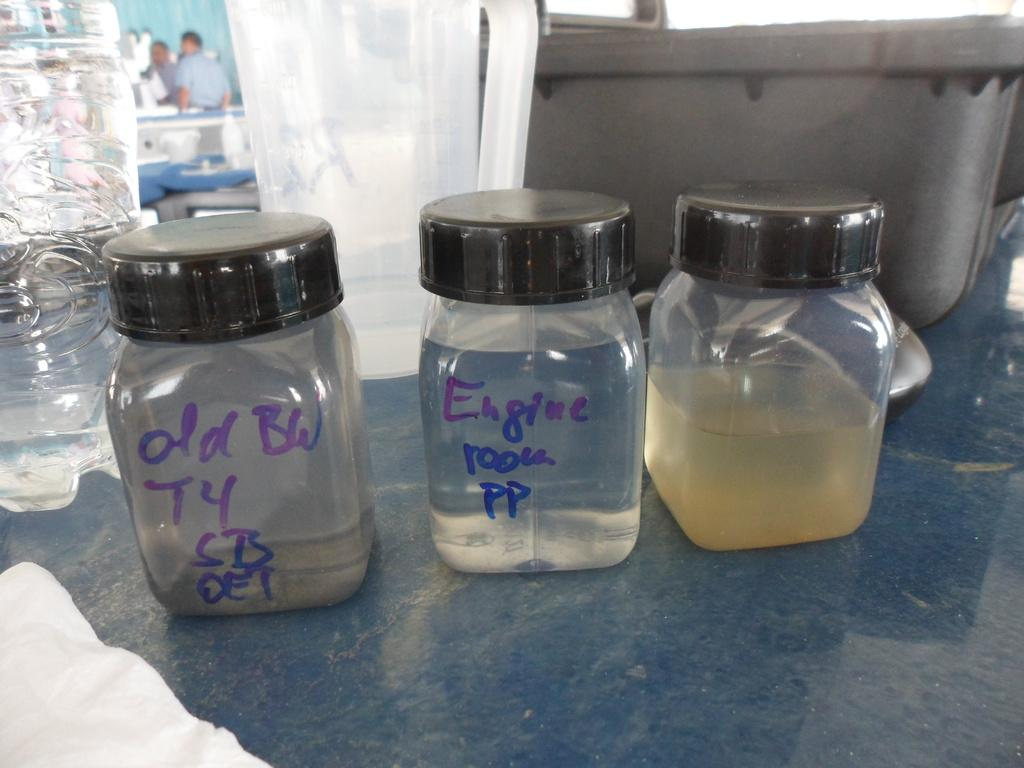Provide a one-sentence caption for the provided image. a jar that says engine room pp in between two other jars. 